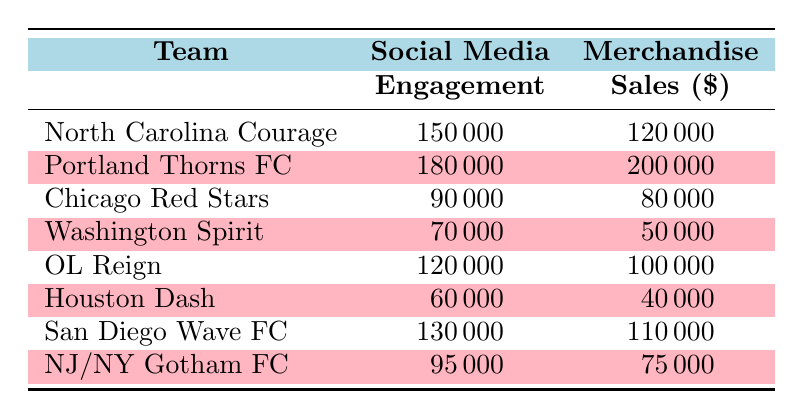What is the social media engagement for Portland Thorns FC? The table shows that the social media engagement for Portland Thorns FC is listed under the "Social Media Engagement" column next to the team name. The value is 180000.
Answer: 180000 Which team has the highest merchandise sales? By looking at the "Merchandise Sales" column, we can see that Portland Thorns FC has the highest sales value of 200000.
Answer: Portland Thorns FC What is the difference in social media engagement between North Carolina Courage and Houston Dash? To find the difference, we subtract the engagement of Houston Dash (60000) from that of North Carolina Courage (150000). This gives us 150000 - 60000 = 90000.
Answer: 90000 Is merchandise sales for OL Reign greater than that of Chicago Red Stars? The table shows the merchandise sales for OL Reign is 100000 and for Chicago Red Stars it is 80000. Since 100000 is greater than 80000, the statement is true.
Answer: Yes What is the average social media engagement of the teams listed in the table? First, we sum the social media engagement values: 150000 + 180000 + 90000 + 70000 + 120000 + 60000 + 130000 + 95000 = 900000. There are 8 teams, so we divide by 8 to find the average: 900000 / 8 = 112500.
Answer: 112500 Which teams have merchandise sales below 100000? By examining the "Merchandise Sales" column, we see that the following teams have sales below 100000: Chicago Red Stars (80000), Washington Spirit (50000), Houston Dash (40000), and NJ/NY Gotham FC (75000).
Answer: Chicago Red Stars, Washington Spirit, Houston Dash, NJ/NY Gotham FC What is the combined total of social media engagement for all teams listed? We need to add all social media engagement values: 150000 + 180000 + 90000 + 70000 + 120000 + 60000 + 130000 + 95000 = 900000, which is the total engagement.
Answer: 900000 Is the merchandise sales of San Diego Wave FC equal to the social media engagement of Chicago Red Stars? San Diego Wave FC has merchandise sales of 110000, while Chicago Red Stars has social media engagement of 90000. Since 110000 is not equal to 90000, the answer is false.
Answer: No 